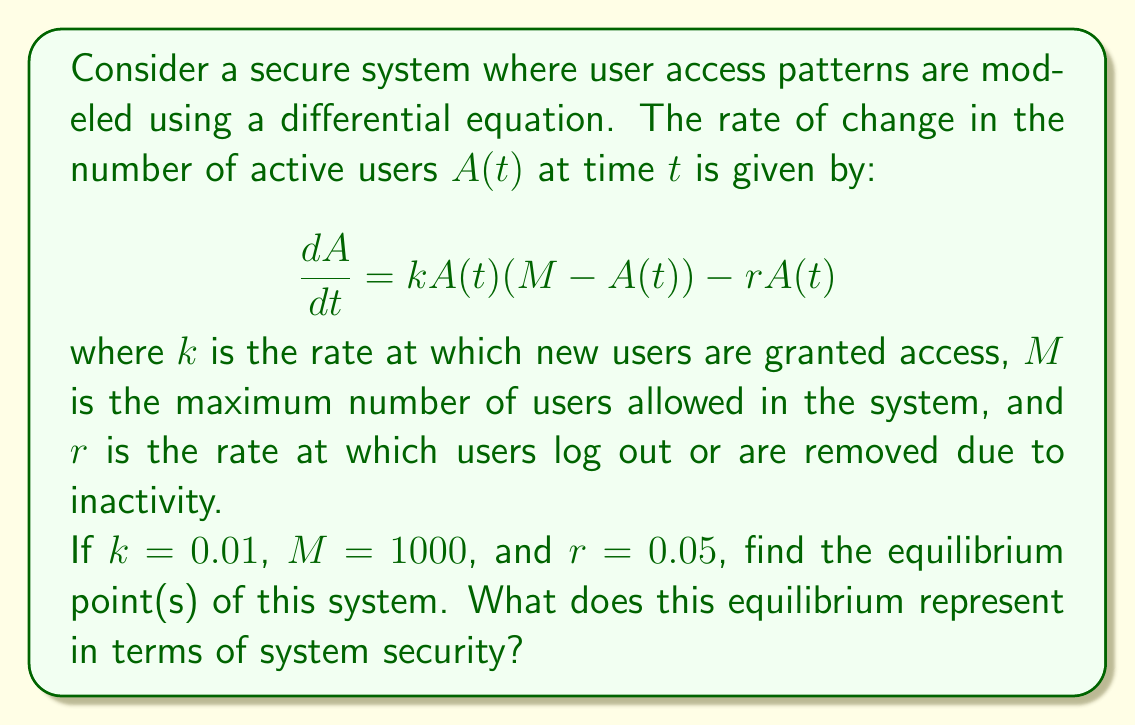Provide a solution to this math problem. To find the equilibrium point(s), we need to set the rate of change to zero:

$$\frac{dA}{dt} = 0$$

Substituting the given equation:

$$0 = kA(M - A) - rA$$

Substituting the given values:

$$0 = 0.01A(1000 - A) - 0.05A$$

Simplifying:

$$0 = 10A - 0.01A^2 - 0.05A$$
$$0 = 9.95A - 0.01A^2$$

Factoring out $A$:

$$A(9.95 - 0.01A) = 0$$

This equation has two solutions:

1. $A = 0$
2. $9.95 - 0.01A = 0$

Solving the second equation:

$$0.01A = 9.95$$
$$A = 995$$

Therefore, the equilibrium points are $A = 0$ and $A = 995$.

In terms of system security:
- $A = 0$ represents a state where no users are active, which is secure but not practical.
- $A = 995$ represents a state where the system has reached a stable number of active users, close to but slightly below the maximum capacity. This equilibrium balances security concerns (not exceeding the maximum) with system utilization.
Answer: Equilibrium points: $A = 0$ and $A = 995$ 